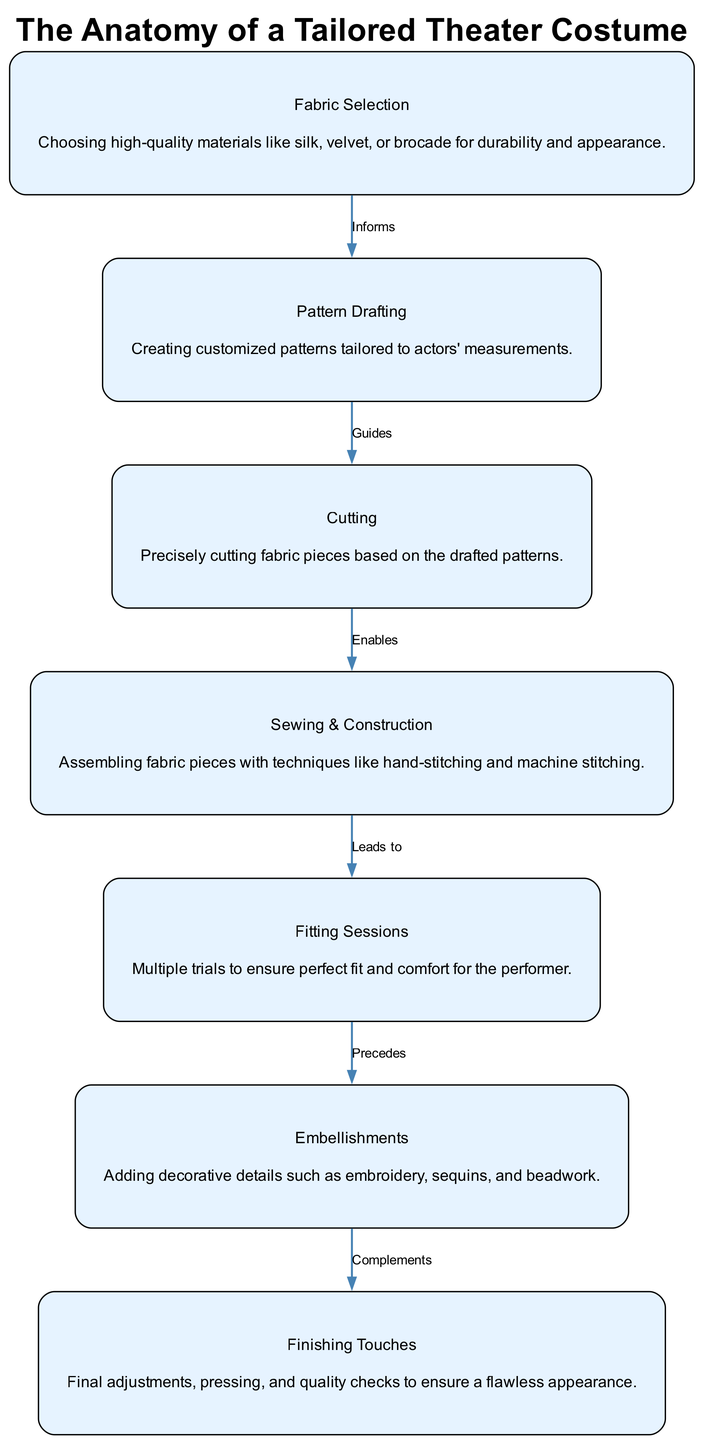What is the first step in the tailoring process? The first step is "Fabric Selection," as shown as the starting point in the diagram. This node is connected to the other steps, indicating it informs the subsequent processes.
Answer: Fabric Selection How many main components are in the diagram? There are six main components, which include Fabric Selection, Pattern Drafting, Cutting, Sewing & Construction, Fitting Sessions, Embellishments, and Finishing Touches.
Answer: Six What guides the cutting process? The cutting process is guided by "Pattern Drafting," as indicated by the edge connecting these two nodes. It shows that the drafted patterns inform how fabric should be cut.
Answer: Pattern Drafting What step comes before the embellishments? The step that comes before the embellishments is "Fitting Sessions," signified by the edge that connects these two nodes, indicating the sequence of the processes.
Answer: Fitting Sessions How does sewing relate to fitting? Sewing leads to fitting, as depicted by the edge between "Sewing & Construction" and "Fitting Sessions." This relationship shows that a garment must be sewn together before fitting can occur.
Answer: Leads to What type of embellishments can be included in a tailored costume? The embellishments can include decorative details such as embroidery, sequins, and beadwork, which are specified in the description of the "Embellishments" node.
Answer: Embroidery, sequins, and beadwork Which step requires multiple trials? The step that requires multiple trials is "Fitting Sessions," as indicated in the description of that node, which emphasizes the importance of ensuring a perfect fit and comfort.
Answer: Fitting Sessions What is the final process in creating the costume? The final process is "Finishing Touches," which is shown as the last node in the diagram, highlighting that it includes final adjustments and quality checks.
Answer: Finishing Touches What complements the finishing touches? The step that complements the finishing touches is "Embellishments," as indicated by the direct connection between these two nodes in the diagram. This shows that embellishments enhance the final appearance.
Answer: Embellishments 